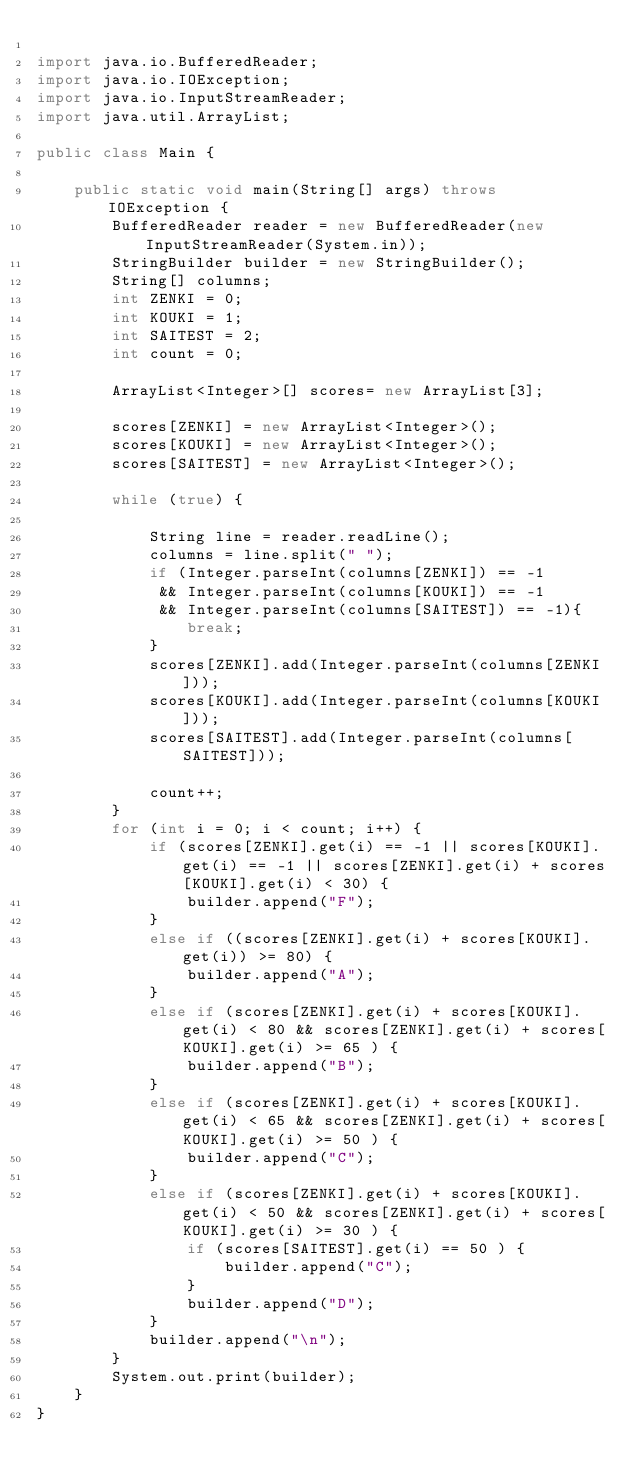Convert code to text. <code><loc_0><loc_0><loc_500><loc_500><_Java_>
import java.io.BufferedReader;
import java.io.IOException;
import java.io.InputStreamReader;
import java.util.ArrayList;

public class Main {

    public static void main(String[] args) throws IOException {
        BufferedReader reader = new BufferedReader(new InputStreamReader(System.in));
        StringBuilder builder = new StringBuilder();
        String[] columns;
        int ZENKI = 0;
        int KOUKI = 1;
        int SAITEST = 2;
        int count = 0;

        ArrayList<Integer>[] scores= new ArrayList[3];

        scores[ZENKI] = new ArrayList<Integer>();
        scores[KOUKI] = new ArrayList<Integer>();
        scores[SAITEST] = new ArrayList<Integer>();

        while (true) {

            String line = reader.readLine();
            columns = line.split(" ");
            if (Integer.parseInt(columns[ZENKI]) == -1 
             && Integer.parseInt(columns[KOUKI]) == -1
             && Integer.parseInt(columns[SAITEST]) == -1){
                break;
            }
            scores[ZENKI].add(Integer.parseInt(columns[ZENKI]));
            scores[KOUKI].add(Integer.parseInt(columns[KOUKI]));
            scores[SAITEST].add(Integer.parseInt(columns[SAITEST]));
            
            count++;
        }
        for (int i = 0; i < count; i++) {
            if (scores[ZENKI].get(i) == -1 || scores[KOUKI].get(i) == -1 || scores[ZENKI].get(i) + scores[KOUKI].get(i) < 30) {
                builder.append("F");
            }
            else if ((scores[ZENKI].get(i) + scores[KOUKI].get(i)) >= 80) {
                builder.append("A");
            }
            else if (scores[ZENKI].get(i) + scores[KOUKI].get(i) < 80 && scores[ZENKI].get(i) + scores[KOUKI].get(i) >= 65 ) {
                builder.append("B");
            }
            else if (scores[ZENKI].get(i) + scores[KOUKI].get(i) < 65 && scores[ZENKI].get(i) + scores[KOUKI].get(i) >= 50 ) {
                builder.append("C");
            }
            else if (scores[ZENKI].get(i) + scores[KOUKI].get(i) < 50 && scores[ZENKI].get(i) + scores[KOUKI].get(i) >= 30 ) {
                if (scores[SAITEST].get(i) == 50 ) {
                    builder.append("C");
                }
                builder.append("D");
            }
            builder.append("\n");
        }
        System.out.print(builder);
    }
}</code> 